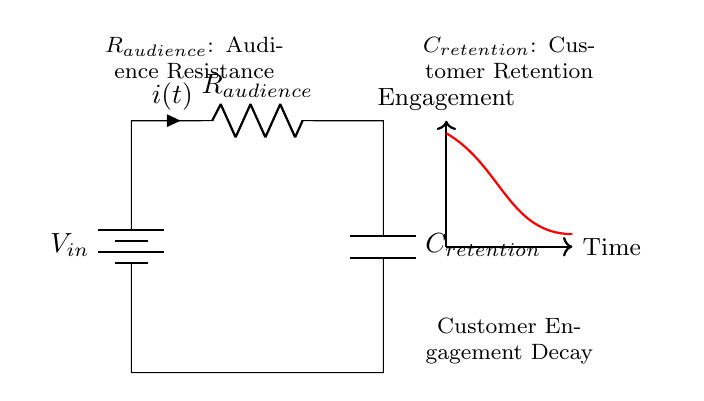What is the input voltage of the circuit? The input voltage, denoted as V_in, is represented by the battery in the circuit diagram. It is typically labeled or indicated near the battery symbol.
Answer: V_in What component represents customer engagement? The red curve in the diagram showcases the decay of customer engagement over time. This visual indicates how engagement decreases.
Answer: Engagement What are the labels for the resistance and capacitance in the circuit? The circuit diagram displays the resistance as R_audience and the capacitance as C_retention. These labels are found next to the respective components.
Answer: R_audience and C_retention How does resistance affect audience engagement? Resistance, indicated by R_audience, represents the factors that inhibit audience engagement. A higher resistance implies lower engagement retention over time.
Answer: Lower engagement What is the expected behavior of the engagement decay over time? The engagement decay is typically exponential, meaning it starts high and decreases rapidly before tapering off. This is consistent with the behavior of an RC circuit.
Answer: Exponential decay What is the physical significance of C_retention? C_retention represents the customer retention capacity, illustrating how well the audience can maintain engagement over time despite diminishing returns.
Answer: Retention capacity 